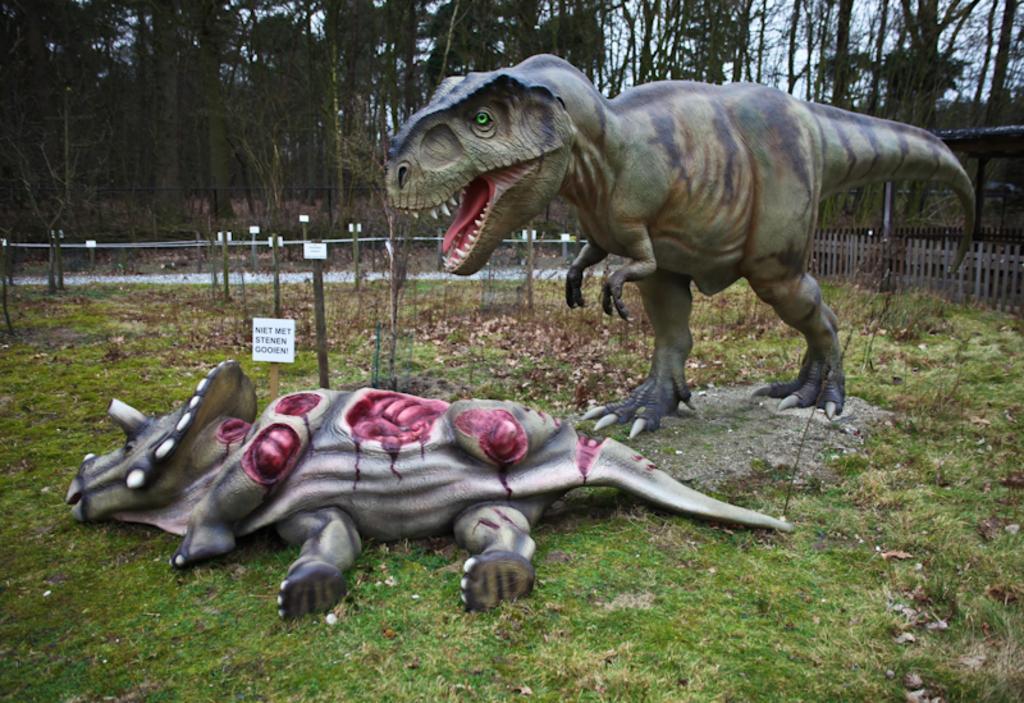In one or two sentences, can you explain what this image depicts? In this image I can see there are 2 dinosaurs dolls in green color, on the right side there is the iron fence and shirt. At the back side there are trees. 